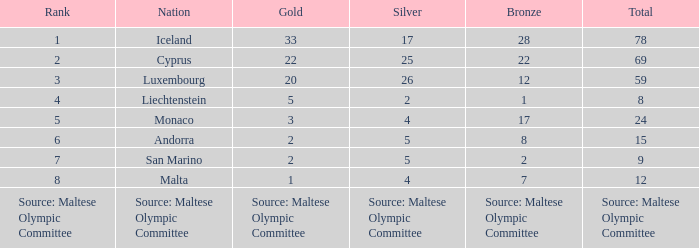What nation has 28 bronze medals? Iceland. 